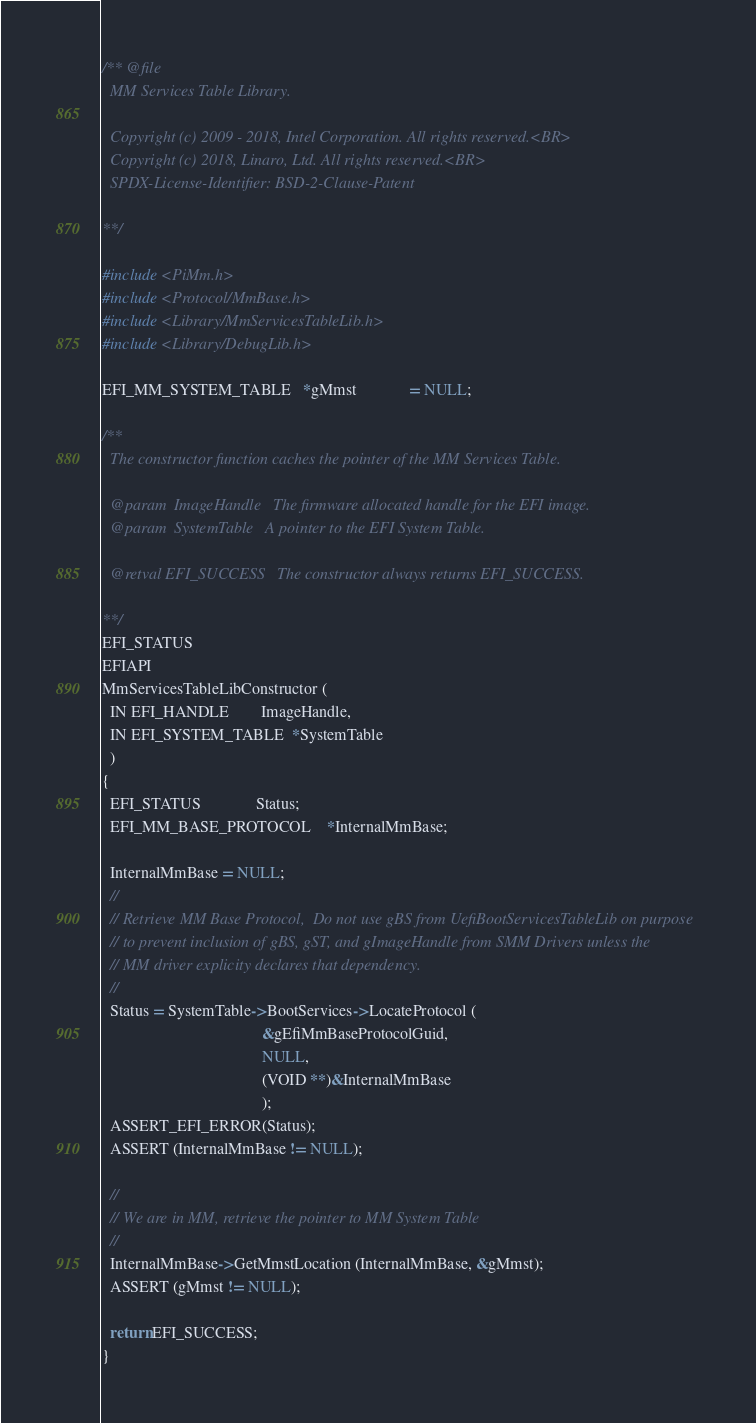<code> <loc_0><loc_0><loc_500><loc_500><_C_>/** @file
  MM Services Table Library.

  Copyright (c) 2009 - 2018, Intel Corporation. All rights reserved.<BR>
  Copyright (c) 2018, Linaro, Ltd. All rights reserved.<BR>
  SPDX-License-Identifier: BSD-2-Clause-Patent

**/

#include <PiMm.h>
#include <Protocol/MmBase.h>
#include <Library/MmServicesTableLib.h>
#include <Library/DebugLib.h>

EFI_MM_SYSTEM_TABLE   *gMmst             = NULL;

/**
  The constructor function caches the pointer of the MM Services Table.

  @param  ImageHandle   The firmware allocated handle for the EFI image.
  @param  SystemTable   A pointer to the EFI System Table.

  @retval EFI_SUCCESS   The constructor always returns EFI_SUCCESS.

**/
EFI_STATUS
EFIAPI
MmServicesTableLibConstructor (
  IN EFI_HANDLE        ImageHandle,
  IN EFI_SYSTEM_TABLE  *SystemTable
  )
{
  EFI_STATUS              Status;
  EFI_MM_BASE_PROTOCOL    *InternalMmBase;

  InternalMmBase = NULL;
  //
  // Retrieve MM Base Protocol,  Do not use gBS from UefiBootServicesTableLib on purpose
  // to prevent inclusion of gBS, gST, and gImageHandle from SMM Drivers unless the
  // MM driver explicity declares that dependency.
  //
  Status = SystemTable->BootServices->LocateProtocol (
                                        &gEfiMmBaseProtocolGuid,
                                        NULL,
                                        (VOID **)&InternalMmBase
                                        );
  ASSERT_EFI_ERROR(Status);
  ASSERT (InternalMmBase != NULL);

  //
  // We are in MM, retrieve the pointer to MM System Table
  //
  InternalMmBase->GetMmstLocation (InternalMmBase, &gMmst);
  ASSERT (gMmst != NULL);

  return EFI_SUCCESS;
}
</code> 